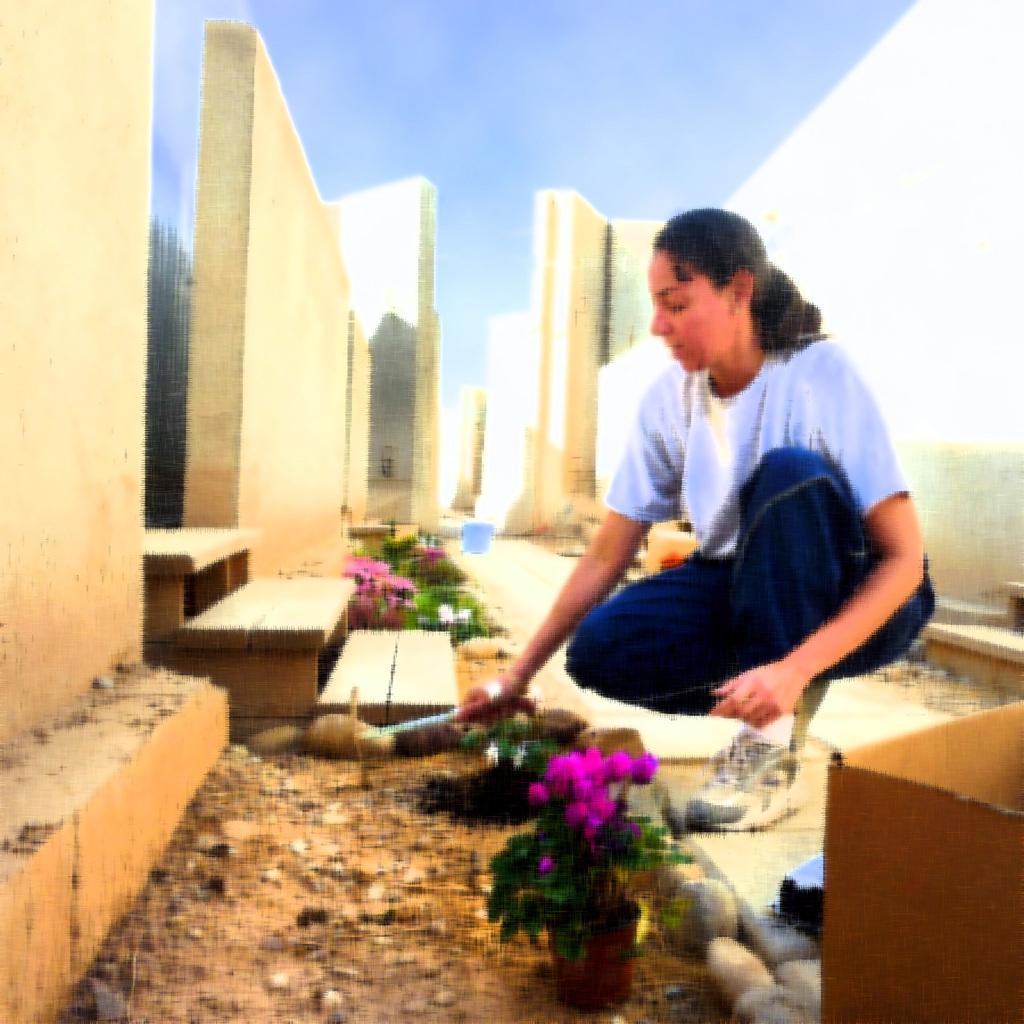How would you summarize this image in a sentence or two? In this image, I can see the woman sitting in squat position and holding an object. At the bottom right corner of the image, It looks like a cardboard box. There are the walls and wooden steps. At the bottom of the bottom of the image, I can see the plants with flowers and the rocks. In the background, there is the sky. 